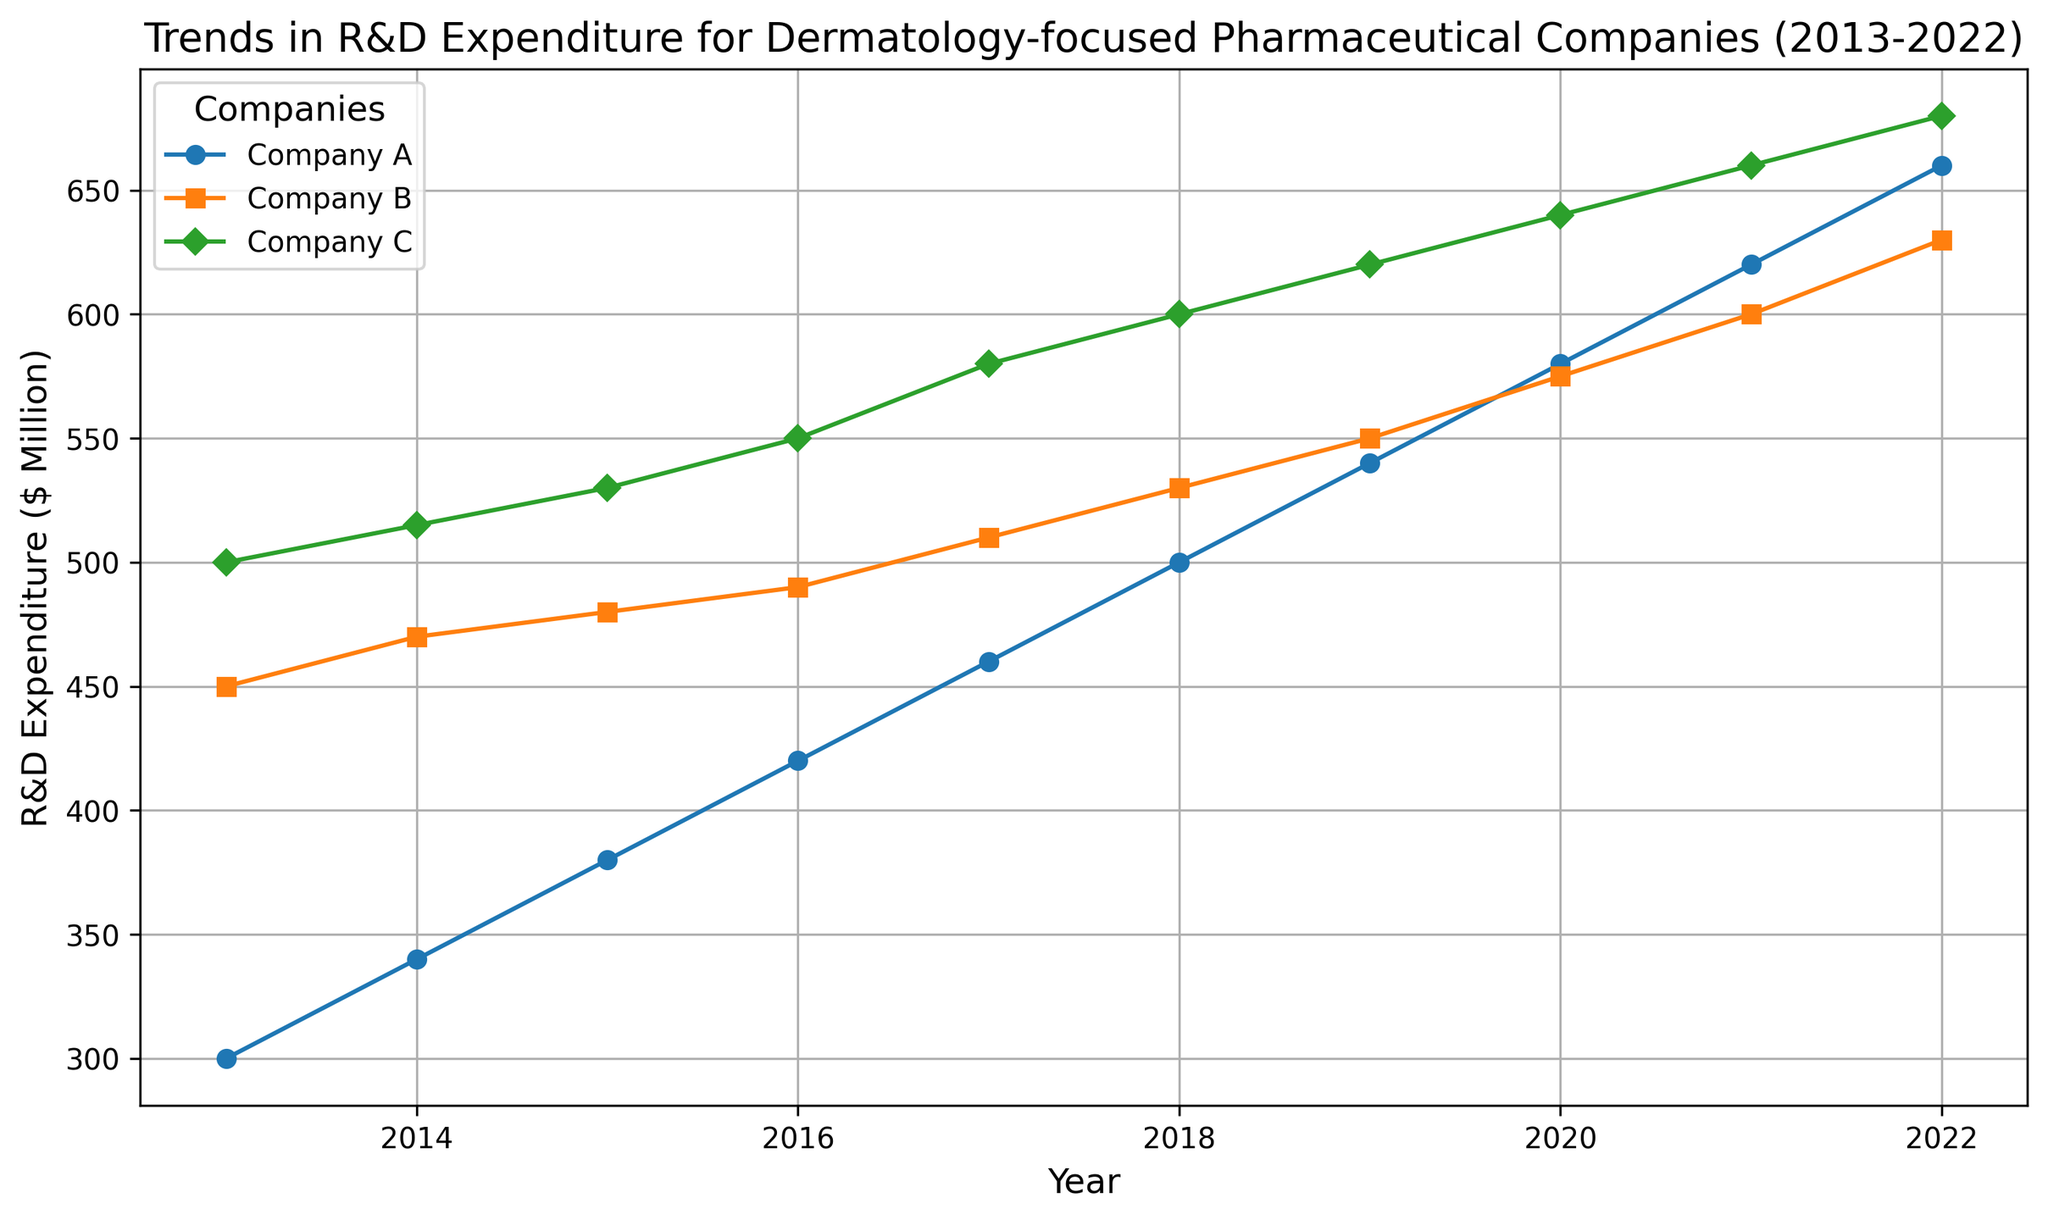What is the overall trend in R&D expenditure for Company A from 2013 to 2022? To determine the overall trend, observe the line representing Company A. Start from the expenditure value in 2013, then follow the line to see if it generally increases, decreases, or remains constant until 2022. The expenditure shows a general rise from 300 to 660 over the years.
Answer: Increasing Which company had the highest R&D expenditure in 2022? Check the endpoint of each line in 2022. Look for the highest value among them. Company C's line reaches 680, the highest among the three.
Answer: Company C In which year did Company B’s R&D expenditure surpass 500 million for the first time? Follow Company B’s line from 2013 onwards and note the year when the line first crosses the 500 mark. It happens in 2017 when the expenditure reaches 510.
Answer: 2017 What is the total R&D expenditure for all companies in 2015? Sum the expenditure of Company A, B, and C for the year 2015. 380 (A) + 480 (B) + 530 (C) = 1390.
Answer: 1390 How much did Company A’s R&D expenditure increase from 2013 to 2020? Subtract the expenditure of Company A in 2013 from its expenditure in 2020. 580 (2020) - 300 (2013) = 280.
Answer: 280 Which company showed the most consistent growth in R&D expenditure over the years? Examine the smoothness and regularity of the slopes of the lines for each company. Company C's line is the smoothest, indicating the most consistent growth.
Answer: Company C In which year did Company C have an expenditure of 550 million? Follow Company C’s line and identify the year it hits the 550 million mark. It occurs in 2016.
Answer: 2016 How does the R&D expenditure trend of Company A compare to Company B in 2021? Look at the values for both companies in 2021. Company A's expenditure is 620, while Company B's is 600. Company A's trend shows slightly higher expenditure than Company B for that year.
Answer: Company A's expenditure is higher Which year saw the highest combined R&D expenditure amongst all three companies? Compare the total expenditure for each year by summing Company A, B, and C's expenditures. The highest combined value is in 2022 with 1970 (660 + 630 + 680).
Answer: 2022 